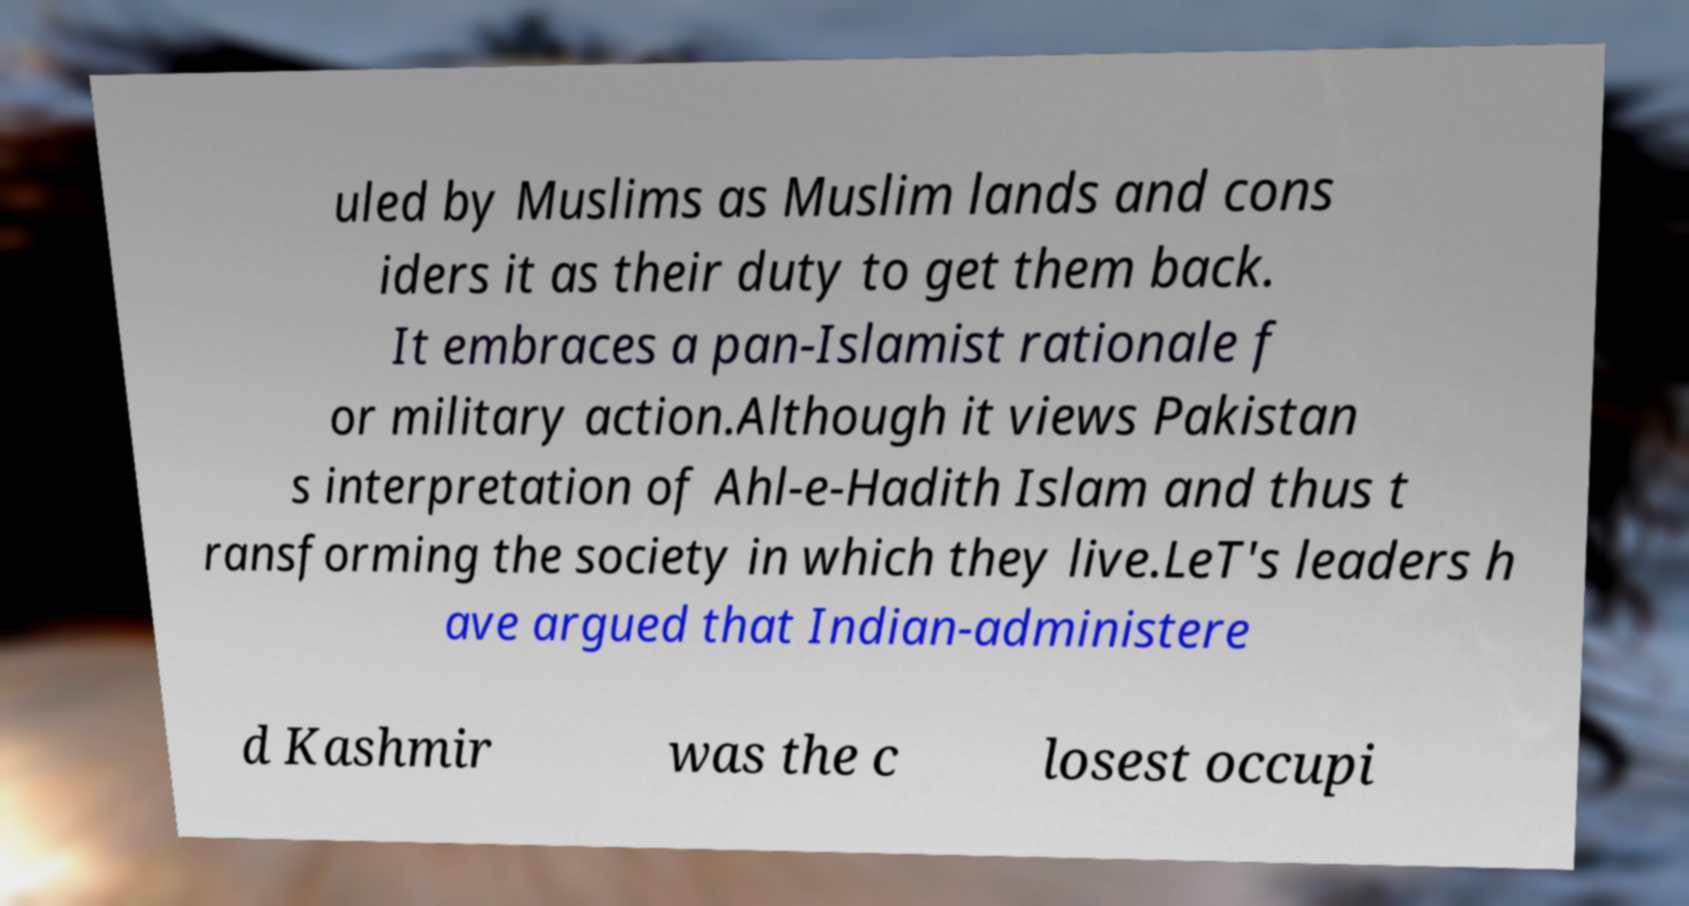What messages or text are displayed in this image? I need them in a readable, typed format. uled by Muslims as Muslim lands and cons iders it as their duty to get them back. It embraces a pan-Islamist rationale f or military action.Although it views Pakistan s interpretation of Ahl-e-Hadith Islam and thus t ransforming the society in which they live.LeT's leaders h ave argued that Indian-administere d Kashmir was the c losest occupi 